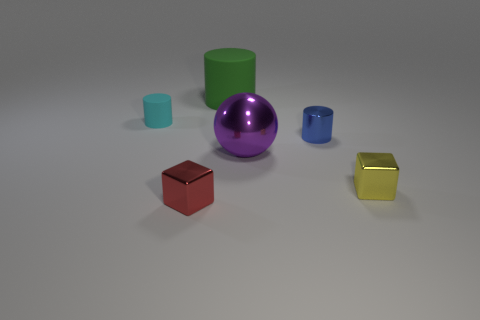Can you describe the lighting in the scene? The scene is softly lit with diffused, omnidirectional lighting, likely coming from an overhead source, creating soft shadows for each object on the ground. 